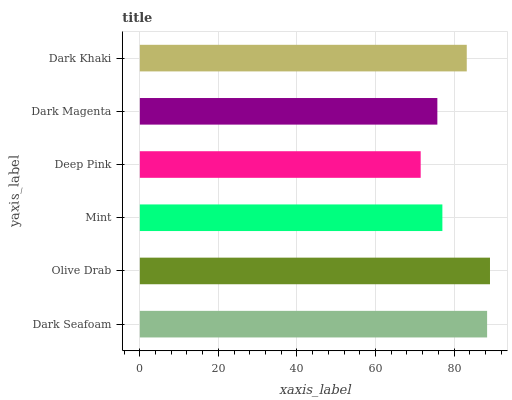Is Deep Pink the minimum?
Answer yes or no. Yes. Is Olive Drab the maximum?
Answer yes or no. Yes. Is Mint the minimum?
Answer yes or no. No. Is Mint the maximum?
Answer yes or no. No. Is Olive Drab greater than Mint?
Answer yes or no. Yes. Is Mint less than Olive Drab?
Answer yes or no. Yes. Is Mint greater than Olive Drab?
Answer yes or no. No. Is Olive Drab less than Mint?
Answer yes or no. No. Is Dark Khaki the high median?
Answer yes or no. Yes. Is Mint the low median?
Answer yes or no. Yes. Is Deep Pink the high median?
Answer yes or no. No. Is Deep Pink the low median?
Answer yes or no. No. 